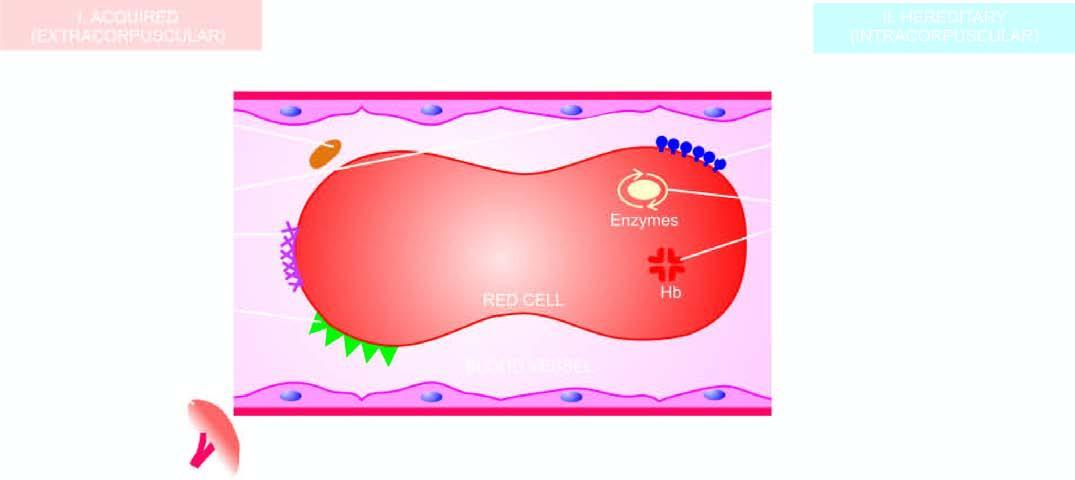what is diagrammatic representation of classification of haemolytic anaemias based on?
Answer the question using a single word or phrase. Principal mechanisms of haemolysis 